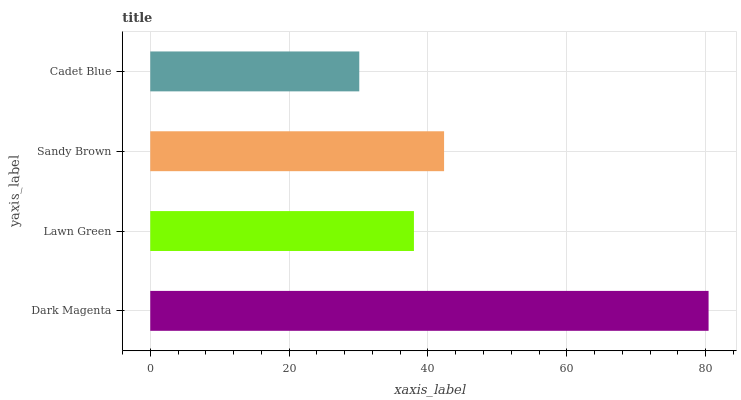Is Cadet Blue the minimum?
Answer yes or no. Yes. Is Dark Magenta the maximum?
Answer yes or no. Yes. Is Lawn Green the minimum?
Answer yes or no. No. Is Lawn Green the maximum?
Answer yes or no. No. Is Dark Magenta greater than Lawn Green?
Answer yes or no. Yes. Is Lawn Green less than Dark Magenta?
Answer yes or no. Yes. Is Lawn Green greater than Dark Magenta?
Answer yes or no. No. Is Dark Magenta less than Lawn Green?
Answer yes or no. No. Is Sandy Brown the high median?
Answer yes or no. Yes. Is Lawn Green the low median?
Answer yes or no. Yes. Is Dark Magenta the high median?
Answer yes or no. No. Is Dark Magenta the low median?
Answer yes or no. No. 